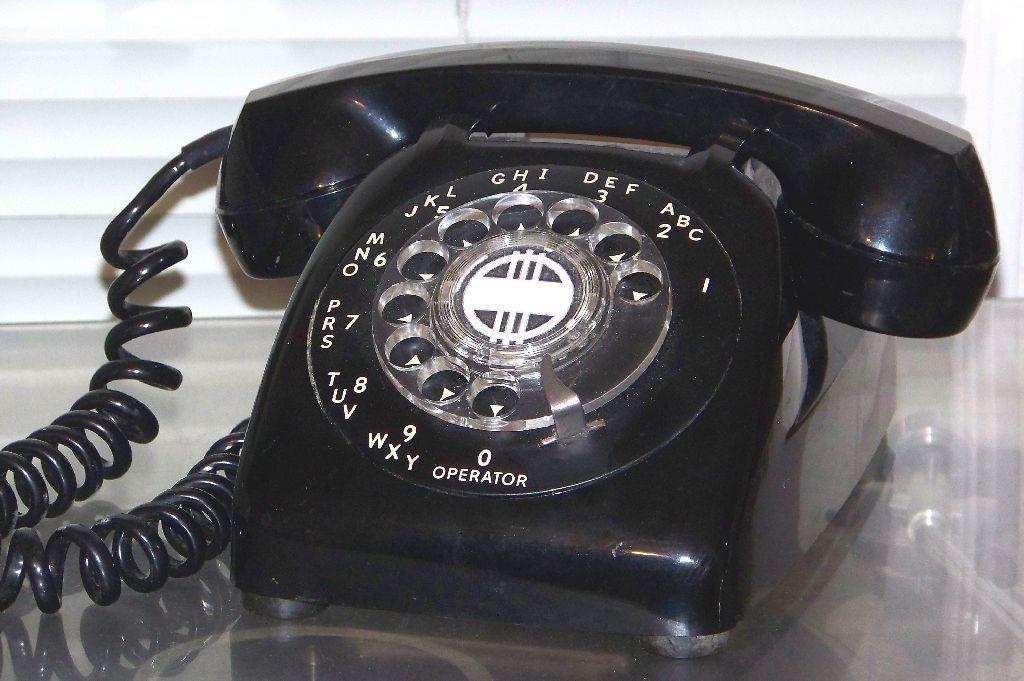Can you describe this image briefly? In this image, we can see a telephone on the glass surface. In the background, we can see the wall. 